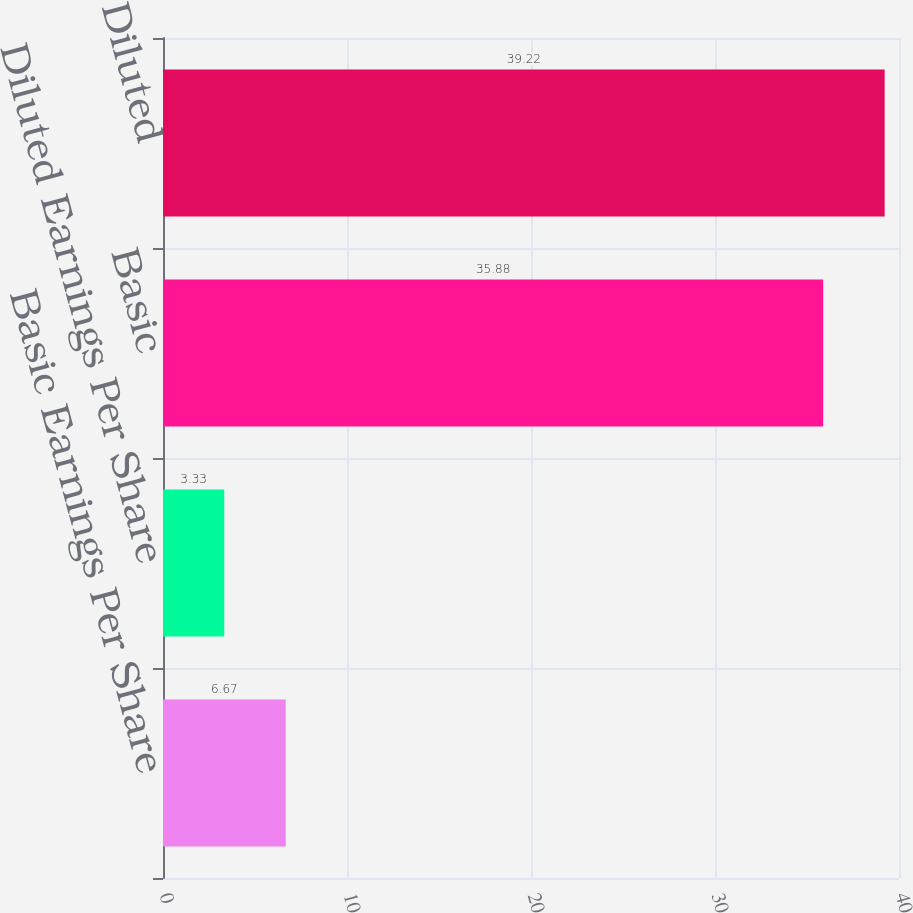Convert chart to OTSL. <chart><loc_0><loc_0><loc_500><loc_500><bar_chart><fcel>Basic Earnings Per Share<fcel>Diluted Earnings Per Share<fcel>Basic<fcel>Diluted<nl><fcel>6.67<fcel>3.33<fcel>35.88<fcel>39.22<nl></chart> 